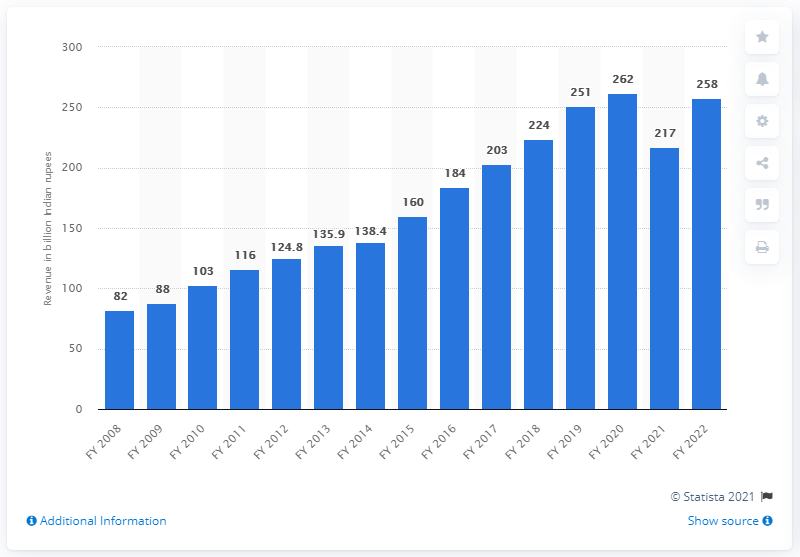Highlight a few significant elements in this photo. In the fiscal year 2020, a total of 262 Indian rupees were collected from television advertisements. 